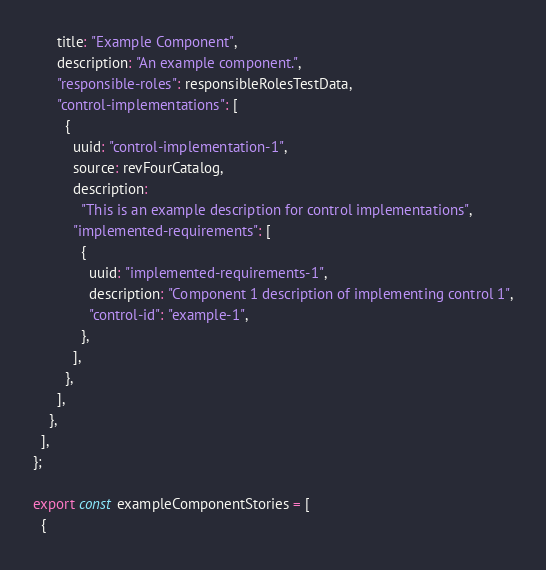Convert code to text. <code><loc_0><loc_0><loc_500><loc_500><_JavaScript_>      title: "Example Component",
      description: "An example component.",
      "responsible-roles": responsibleRolesTestData,
      "control-implementations": [
        {
          uuid: "control-implementation-1",
          source: revFourCatalog,
          description:
            "This is an example description for control implementations",
          "implemented-requirements": [
            {
              uuid: "implemented-requirements-1",
              description: "Component 1 description of implementing control 1",
              "control-id": "example-1",
            },
          ],
        },
      ],
    },
  ],
};

export const exampleComponentStories = [
  {</code> 